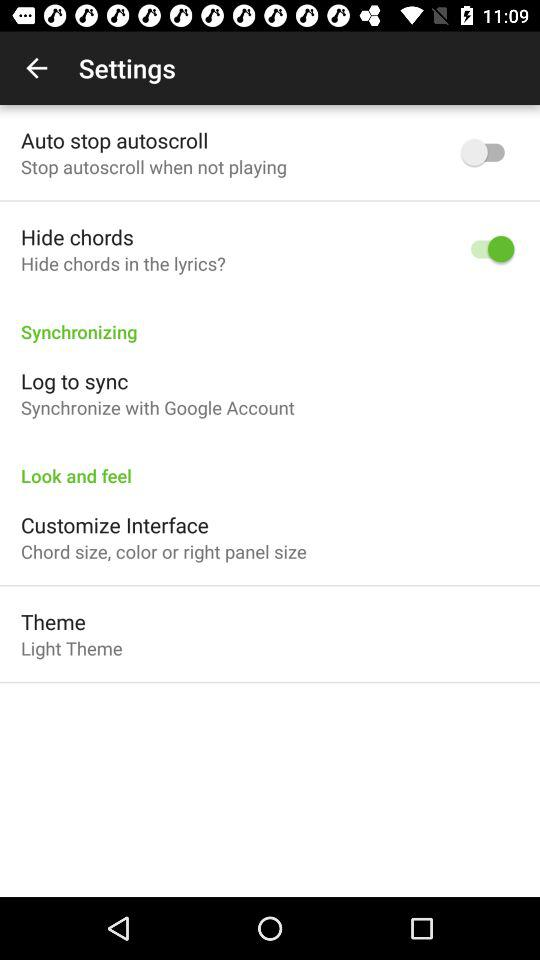What is the status of the "Auto-stop autoscroll" setting? The status of the "Auto-stop autoscroll" setting is "off". 